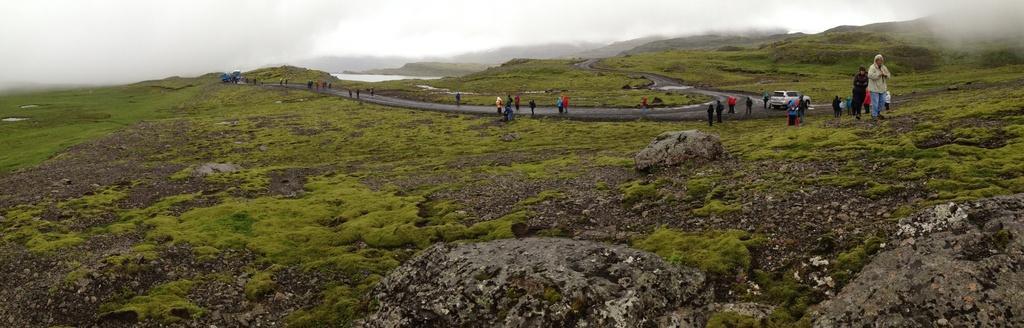Could you give a brief overview of what you see in this image? Here we can see grass on the ground. In the background there are few people standing and few are walking on the ground. On the right there is a vehicle and we can also see water and smoke over here. 